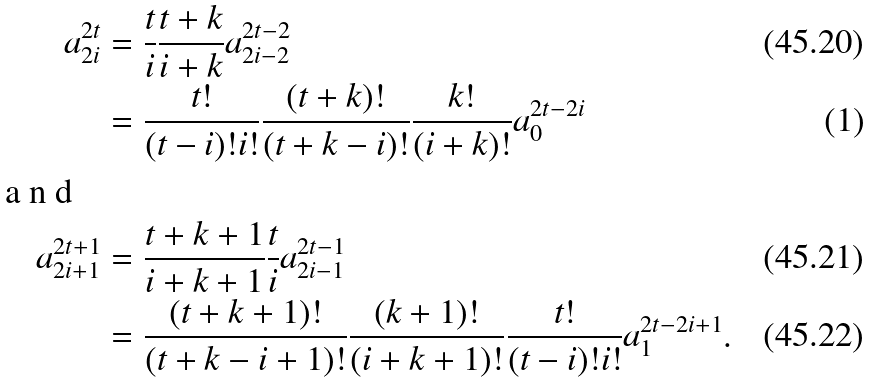Convert formula to latex. <formula><loc_0><loc_0><loc_500><loc_500>a _ { 2 i } ^ { 2 t } & = \frac { t } { i } \frac { t + k } { i + k } a _ { 2 i - 2 } ^ { 2 t - 2 } \\ & = \frac { t ! } { ( t - i ) ! i ! } \frac { ( t + k ) ! } { ( t + k - i ) ! } \frac { k ! } { ( i + k ) ! } a ^ { 2 t - 2 i } _ { 0 } \intertext { a n d } a _ { 2 i + 1 } ^ { 2 t + 1 } & = \frac { t + k + 1 } { i + k + 1 } \frac { t } { i } a _ { 2 i - 1 } ^ { 2 t - 1 } \\ & = \frac { ( t + k + 1 ) ! } { ( t + k - i + 1 ) ! } \frac { ( k + 1 ) ! } { ( i + k + 1 ) ! } \frac { t ! } { ( t - i ) ! i ! } a ^ { 2 t - 2 i + 1 } _ { 1 } .</formula> 